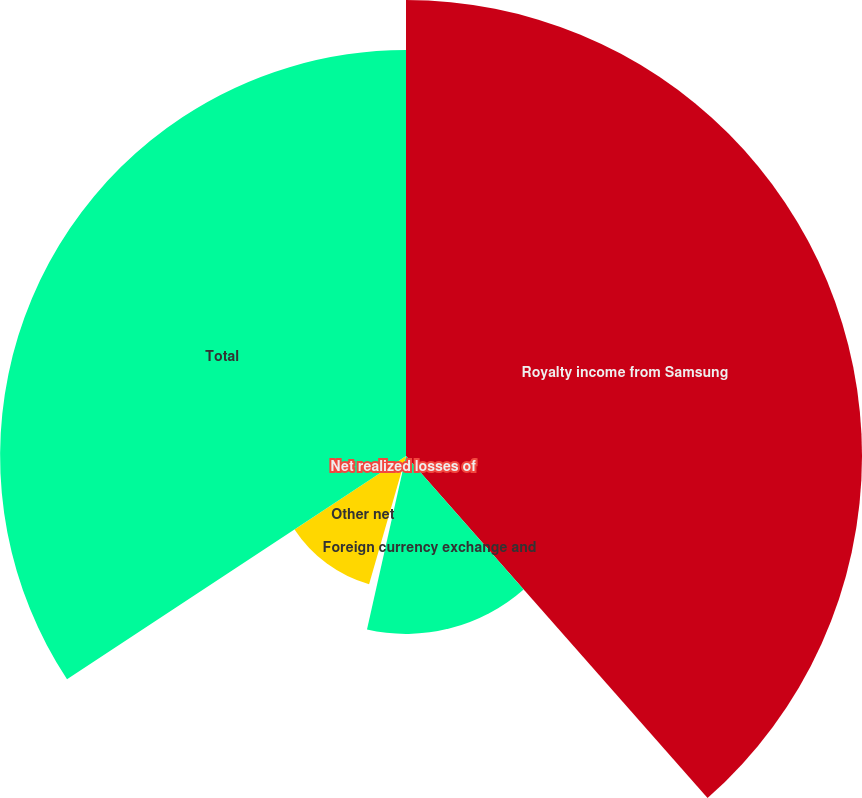<chart> <loc_0><loc_0><loc_500><loc_500><pie_chart><fcel>Royalty income from Samsung<fcel>Foreign currency exchange and<fcel>Net realized losses of<fcel>Other net<fcel>Total<nl><fcel>38.5%<fcel>15.02%<fcel>0.94%<fcel>11.27%<fcel>34.27%<nl></chart> 